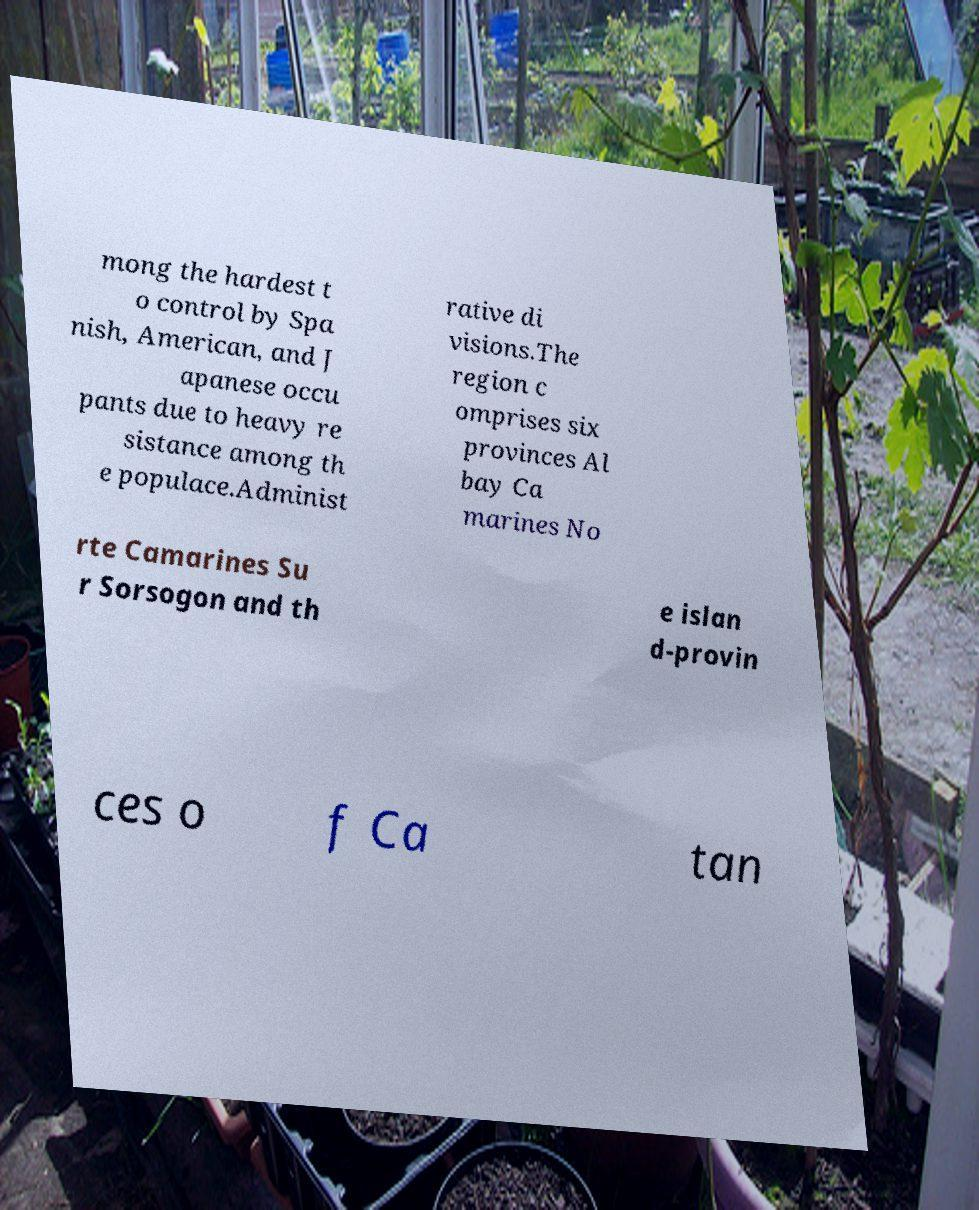I need the written content from this picture converted into text. Can you do that? mong the hardest t o control by Spa nish, American, and J apanese occu pants due to heavy re sistance among th e populace.Administ rative di visions.The region c omprises six provinces Al bay Ca marines No rte Camarines Su r Sorsogon and th e islan d-provin ces o f Ca tan 